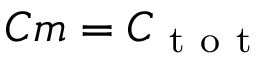Convert formula to latex. <formula><loc_0><loc_0><loc_500><loc_500>C m = C _ { t o t }</formula> 